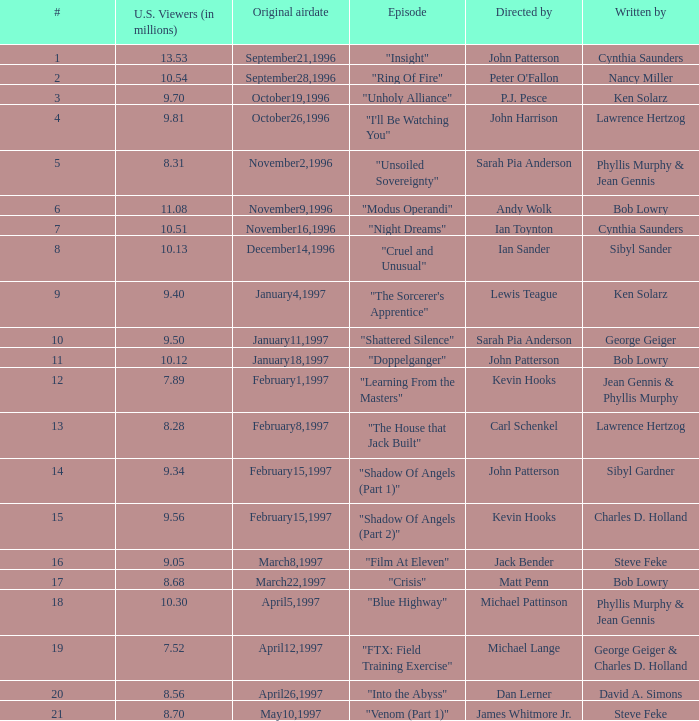What are the titles of episodes numbered 19? "FTX: Field Training Exercise". 